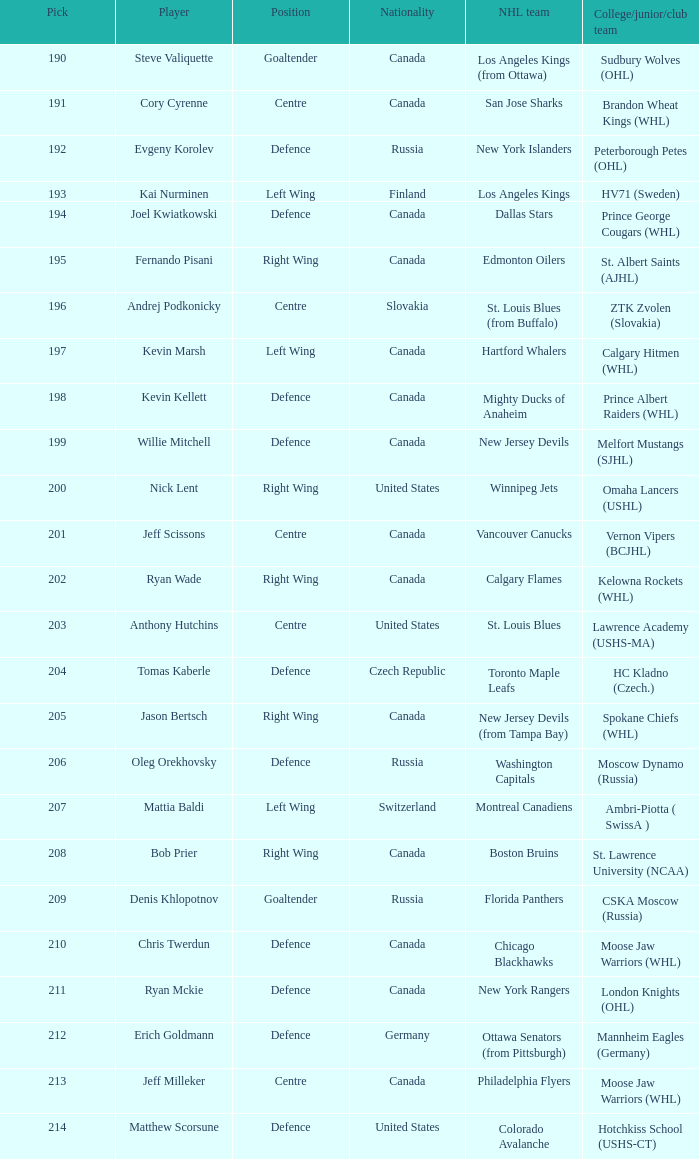What is the top choice for evgeny korolev? 192.0. 